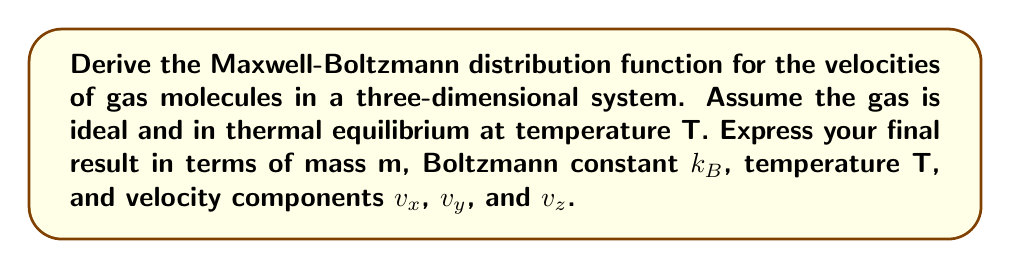Teach me how to tackle this problem. 1. Start with the Boltzmann distribution for energy:
   $$f(E) \propto e^{-E/k_BT}$$

2. For an ideal gas, the energy of a molecule is purely kinetic:
   $$E = \frac{1}{2}m(v_x^2 + v_y^2 + v_z^2)$$

3. Substitute this energy into the Boltzmann distribution:
   $$f(v_x, v_y, v_z) \propto e^{-m(v_x^2 + v_y^2 + v_z^2)/(2k_BT)}$$

4. The distribution must be normalized, so we need to find the normalization constant:
   $$\int_{-\infty}^{\infty}\int_{-\infty}^{\infty}\int_{-\infty}^{\infty} f(v_x, v_y, v_z) dv_x dv_y dv_z = 1$$

5. Solve this triple integral:
   $$\int_{-\infty}^{\infty}\int_{-\infty}^{\infty}\int_{-\infty}^{\infty} A e^{-m(v_x^2 + v_y^2 + v_z^2)/(2k_BT)} dv_x dv_y dv_z = 1$$
   where A is the normalization constant.

6. Each integral is a Gaussian integral, which evaluates to:
   $$A \left(\sqrt{\frac{2\pi k_BT}{m}}\right)^3 = 1$$

7. Solve for A:
   $$A = \left(\frac{m}{2\pi k_BT}\right)^{3/2}$$

8. The final Maxwell-Boltzmann distribution is:
   $$f(v_x, v_y, v_z) = \left(\frac{m}{2\pi k_BT}\right)^{3/2} e^{-m(v_x^2 + v_y^2 + v_z^2)/(2k_BT)}$$
Answer: $$f(v_x, v_y, v_z) = \left(\frac{m}{2\pi k_BT}\right)^{3/2} e^{-m(v_x^2 + v_y^2 + v_z^2)/(2k_BT)}$$ 